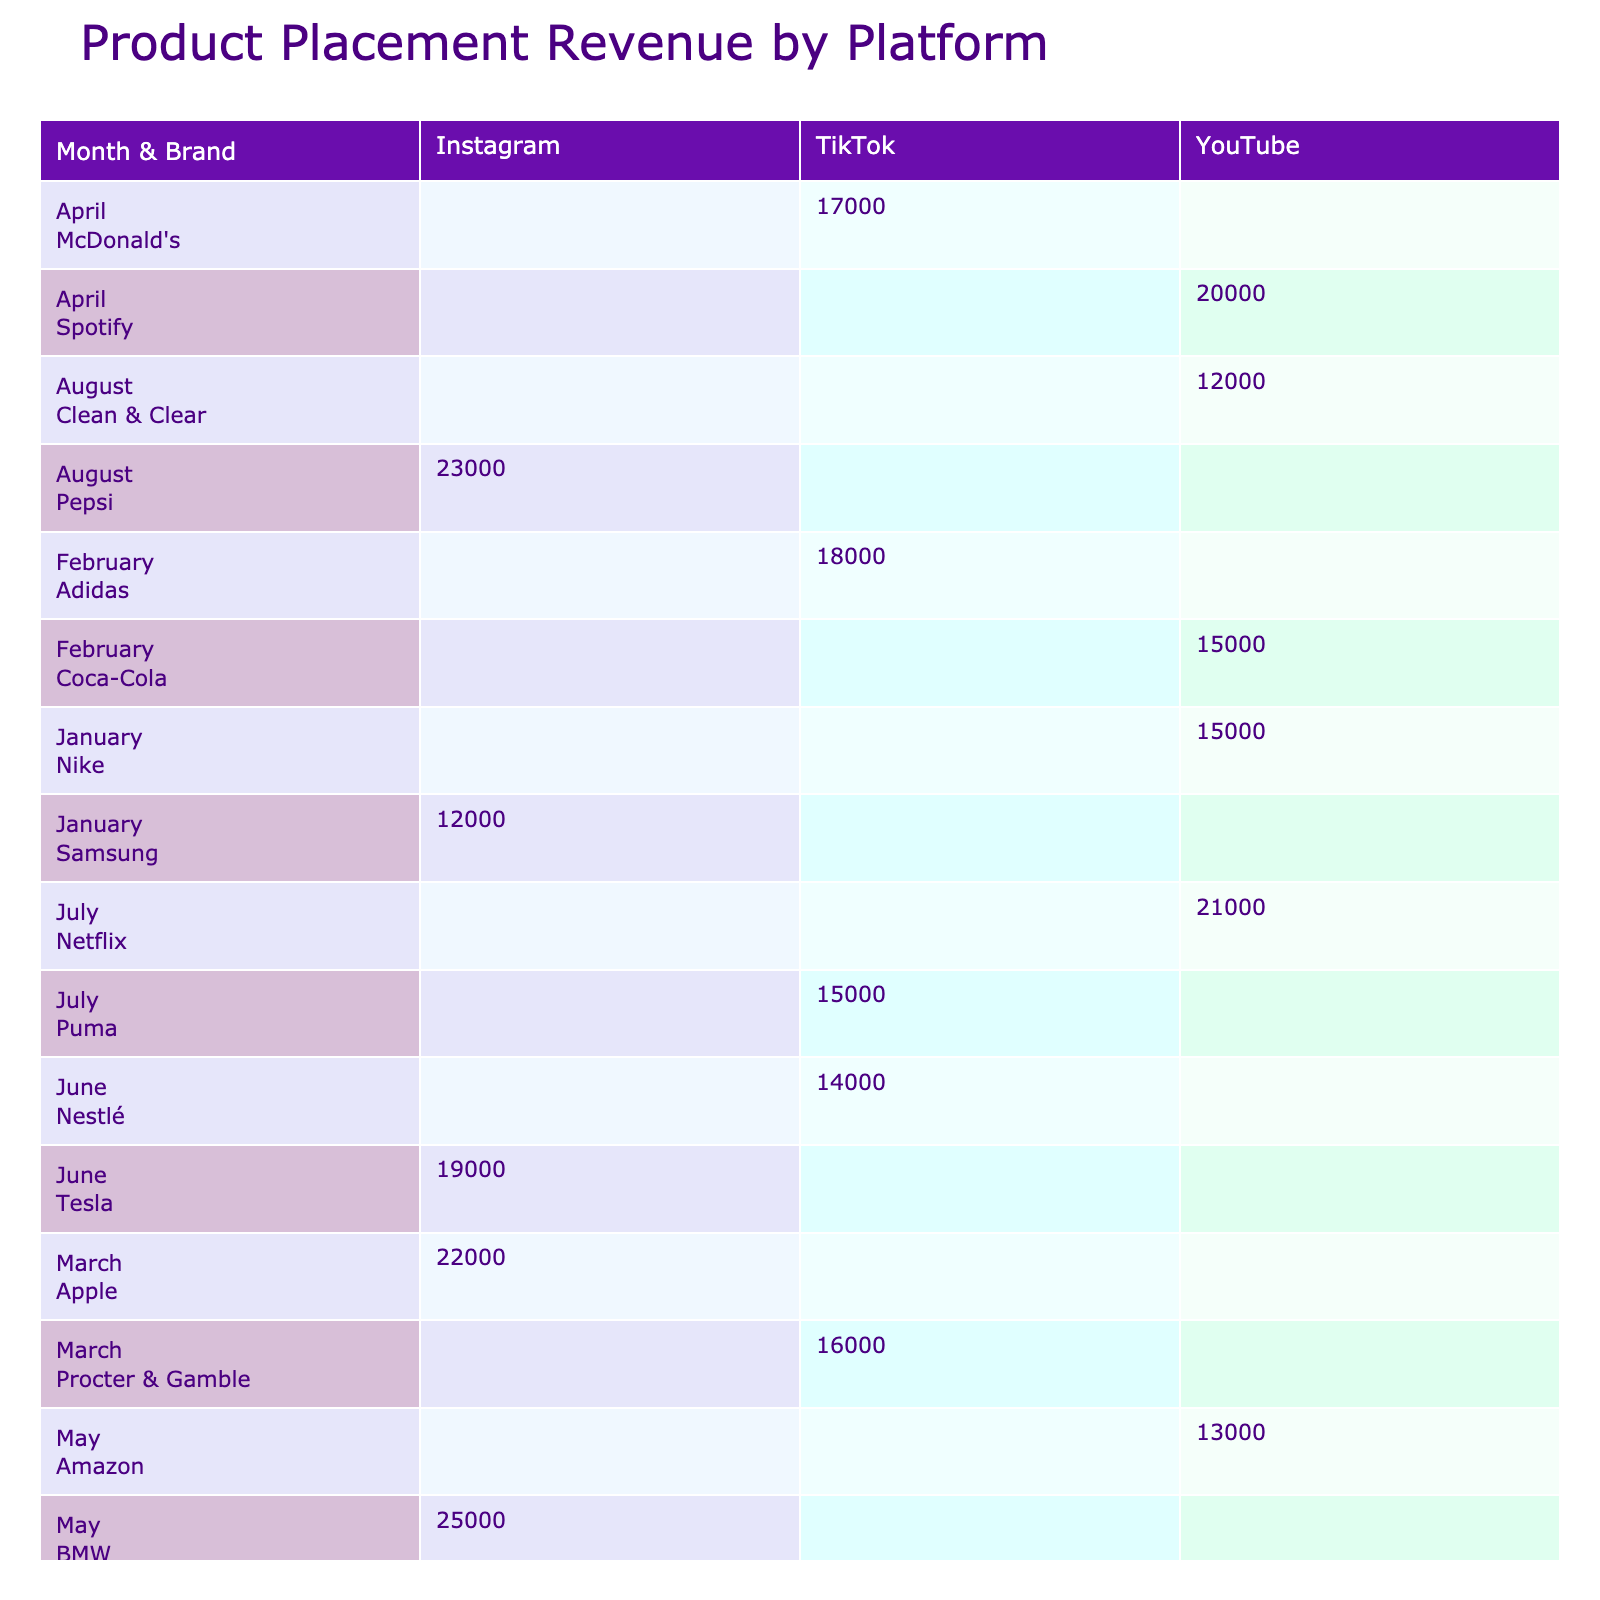What was the highest revenue from a brand in October? In October, the brand Huda Beauty generated a revenue of 30,000, which is the highest revenue listed for that month.
Answer: 30,000 Which platform had the lowest revenue in January? In January, the platform with the lowest revenue was Instagram, with a total revenue of 12,000 from Samsung.
Answer: 12,000 What is the average revenue for TikTok collaborations? The total revenue for TikTok collaborations is 18,000 + 16,000 + 17,000 + 15,000 + 18,000 = 84,000. There are 5 entries, so the average is 84,000/5 = 16,800.
Answer: 16,800 Did any brand achieve a revenue above 25,000? Yes, both BMW and Huda Beauty achieved revenues above 25,000 in May and October, respectively.
Answer: Yes What was the total revenue generated by YouTube partnerships over the year? The total revenue from YouTube is 15,000 + 15,000 + 20,000 + 13,000 + 21,000 + 12,000 + 17,000 = 113,000.
Answer: 113,000 Which month had the highest total revenue across all brands? To find the month with the highest total, we look at the monthly revenues: January (27,000), February (33,000), March (38,000), April (37,000), May (38,000), June (33,000), July (36,000), August (35,000), September (33,000), and October (48,000). October had the highest total revenue of 48,000.
Answer: October How much revenue did Adidas generate, and what was the engagement rate? Adidas generated a revenue of 18,000 in February, and its engagement rate was 11.8%.
Answer: 18,000, 11.8% Which brand had the highest engagement rate for TikTok in June? The brand Tesla had the highest engagement rate in June for TikTok, with a value of 17.5%.
Answer: 17.5% Compare the revenues from April and August. Which month had a higher total? In April, the total revenue was 37,000, while in August, it was 35,000. Thus, April had a higher total revenue than August by 2,000.
Answer: April Is there a trend in revenue growth for brands throughout the year? Analyzing the monthly revenues, we can see fluctuations in revenue with peaks in May, July, and October indicating a general trend upward towards the latter part of the year, especially with spikes in activity from certain brands.
Answer: Yes 